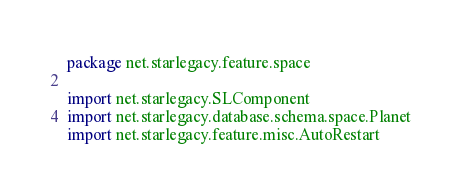<code> <loc_0><loc_0><loc_500><loc_500><_Kotlin_>package net.starlegacy.feature.space

import net.starlegacy.SLComponent
import net.starlegacy.database.schema.space.Planet
import net.starlegacy.feature.misc.AutoRestart</code> 